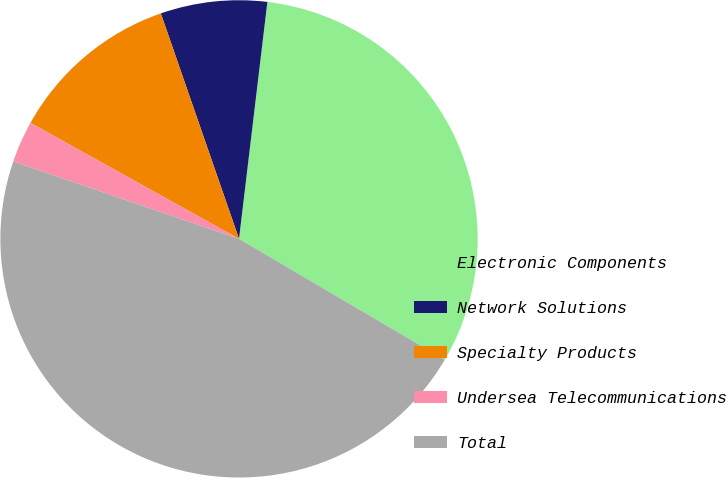<chart> <loc_0><loc_0><loc_500><loc_500><pie_chart><fcel>Electronic Components<fcel>Network Solutions<fcel>Specialty Products<fcel>Undersea Telecommunications<fcel>Total<nl><fcel>31.56%<fcel>7.21%<fcel>11.61%<fcel>2.82%<fcel>46.8%<nl></chart> 